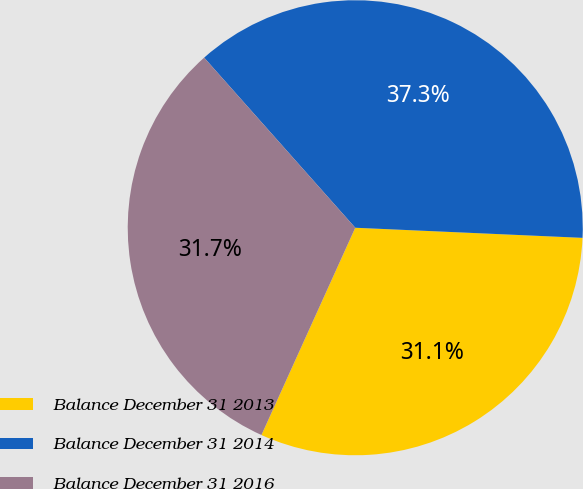<chart> <loc_0><loc_0><loc_500><loc_500><pie_chart><fcel>Balance December 31 2013<fcel>Balance December 31 2014<fcel>Balance December 31 2016<nl><fcel>31.06%<fcel>37.27%<fcel>31.68%<nl></chart> 